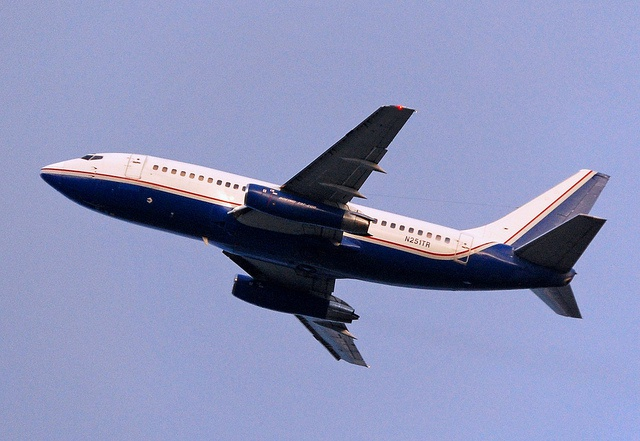Describe the objects in this image and their specific colors. I can see a airplane in darkgray, black, lightgray, navy, and gray tones in this image. 